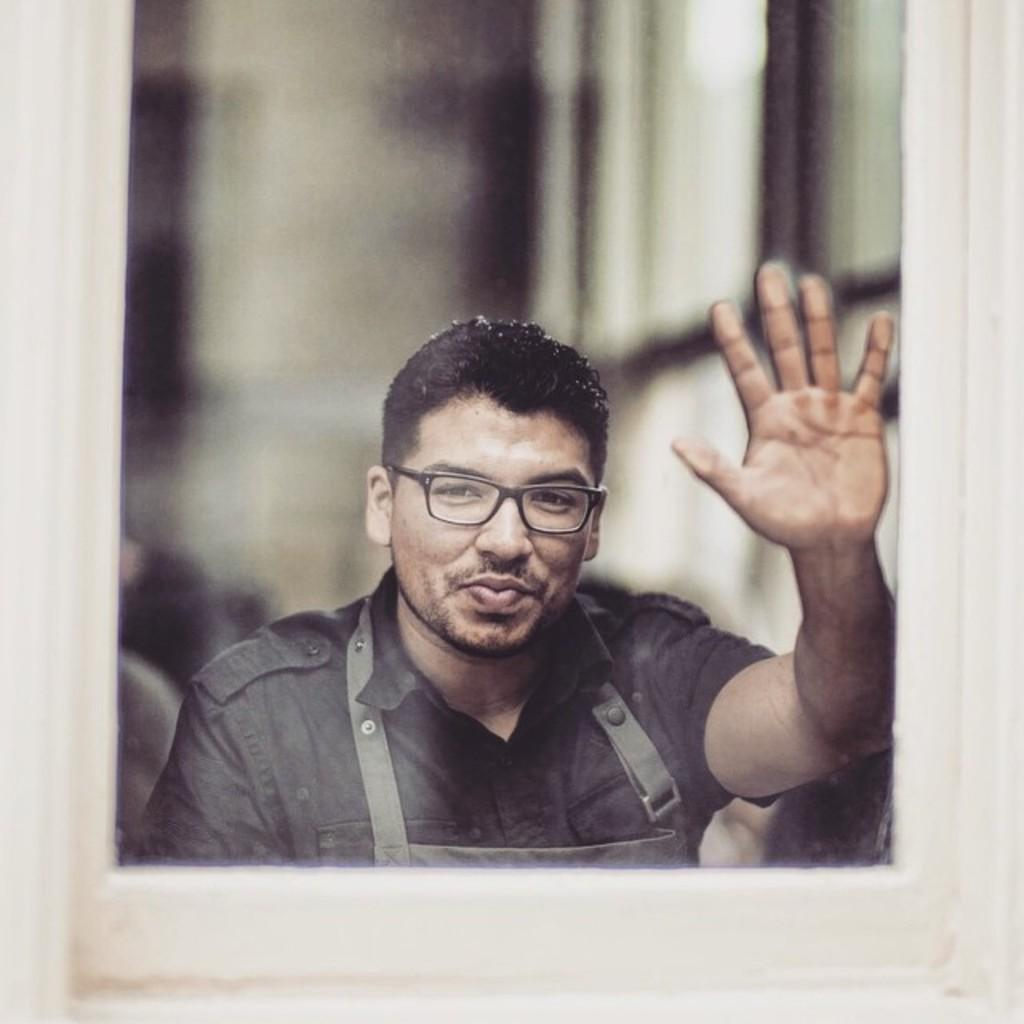What object is present in the image that contains a picture? There is a photo frame in the image. Who is in the photo inside the frame? The photo frame contains a man. What is the man wearing in the photo? The man is wearing a black shirt. How is the background of the photo depicted? The background of the photo is blurred. What color is the frame of the photo? The frame of the photo is white. How many trucks are visible in the image? There are no trucks present in the image. What color is the crayon used to draw the man in the photo? The image is a photograph, not a drawing, so there is no crayon used to depict the man. 